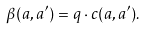Convert formula to latex. <formula><loc_0><loc_0><loc_500><loc_500>\beta ( a , a ^ { \prime } ) = q \cdot c ( a , a ^ { \prime } ) .</formula> 